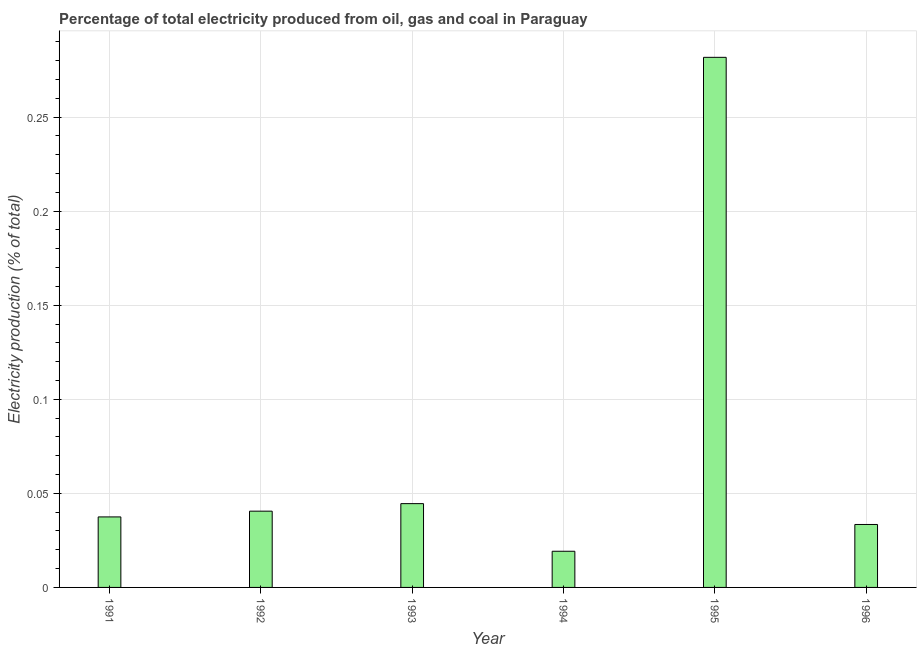Does the graph contain any zero values?
Your answer should be compact. No. What is the title of the graph?
Give a very brief answer. Percentage of total electricity produced from oil, gas and coal in Paraguay. What is the label or title of the Y-axis?
Offer a very short reply. Electricity production (% of total). What is the electricity production in 1993?
Your answer should be very brief. 0.04. Across all years, what is the maximum electricity production?
Provide a succinct answer. 0.28. Across all years, what is the minimum electricity production?
Your answer should be compact. 0.02. In which year was the electricity production minimum?
Offer a terse response. 1994. What is the sum of the electricity production?
Provide a short and direct response. 0.46. What is the difference between the electricity production in 1991 and 1996?
Provide a succinct answer. 0. What is the average electricity production per year?
Make the answer very short. 0.08. What is the median electricity production?
Make the answer very short. 0.04. In how many years, is the electricity production greater than 0.05 %?
Make the answer very short. 1. Do a majority of the years between 1994 and 1996 (inclusive) have electricity production greater than 0.01 %?
Provide a short and direct response. Yes. What is the ratio of the electricity production in 1995 to that in 1996?
Your answer should be compact. 8.42. Is the electricity production in 1992 less than that in 1993?
Ensure brevity in your answer.  Yes. Is the difference between the electricity production in 1995 and 1996 greater than the difference between any two years?
Offer a very short reply. No. What is the difference between the highest and the second highest electricity production?
Provide a short and direct response. 0.24. Is the sum of the electricity production in 1991 and 1994 greater than the maximum electricity production across all years?
Your answer should be very brief. No. What is the difference between the highest and the lowest electricity production?
Your answer should be compact. 0.26. In how many years, is the electricity production greater than the average electricity production taken over all years?
Your answer should be very brief. 1. How many bars are there?
Offer a terse response. 6. Are all the bars in the graph horizontal?
Make the answer very short. No. How many years are there in the graph?
Make the answer very short. 6. Are the values on the major ticks of Y-axis written in scientific E-notation?
Provide a succinct answer. No. What is the Electricity production (% of total) of 1991?
Offer a very short reply. 0.04. What is the Electricity production (% of total) in 1992?
Your response must be concise. 0.04. What is the Electricity production (% of total) of 1993?
Provide a short and direct response. 0.04. What is the Electricity production (% of total) of 1994?
Your answer should be compact. 0.02. What is the Electricity production (% of total) in 1995?
Your response must be concise. 0.28. What is the Electricity production (% of total) in 1996?
Make the answer very short. 0.03. What is the difference between the Electricity production (% of total) in 1991 and 1992?
Offer a terse response. -0. What is the difference between the Electricity production (% of total) in 1991 and 1993?
Provide a succinct answer. -0.01. What is the difference between the Electricity production (% of total) in 1991 and 1994?
Your answer should be compact. 0.02. What is the difference between the Electricity production (% of total) in 1991 and 1995?
Provide a succinct answer. -0.24. What is the difference between the Electricity production (% of total) in 1991 and 1996?
Ensure brevity in your answer.  0. What is the difference between the Electricity production (% of total) in 1992 and 1993?
Offer a very short reply. -0. What is the difference between the Electricity production (% of total) in 1992 and 1994?
Provide a succinct answer. 0.02. What is the difference between the Electricity production (% of total) in 1992 and 1995?
Your response must be concise. -0.24. What is the difference between the Electricity production (% of total) in 1992 and 1996?
Make the answer very short. 0.01. What is the difference between the Electricity production (% of total) in 1993 and 1994?
Offer a terse response. 0.03. What is the difference between the Electricity production (% of total) in 1993 and 1995?
Offer a terse response. -0.24. What is the difference between the Electricity production (% of total) in 1993 and 1996?
Give a very brief answer. 0.01. What is the difference between the Electricity production (% of total) in 1994 and 1995?
Give a very brief answer. -0.26. What is the difference between the Electricity production (% of total) in 1994 and 1996?
Your answer should be compact. -0.01. What is the difference between the Electricity production (% of total) in 1995 and 1996?
Your answer should be very brief. 0.25. What is the ratio of the Electricity production (% of total) in 1991 to that in 1992?
Your answer should be very brief. 0.93. What is the ratio of the Electricity production (% of total) in 1991 to that in 1993?
Your answer should be compact. 0.84. What is the ratio of the Electricity production (% of total) in 1991 to that in 1994?
Offer a very short reply. 1.95. What is the ratio of the Electricity production (% of total) in 1991 to that in 1995?
Your response must be concise. 0.13. What is the ratio of the Electricity production (% of total) in 1991 to that in 1996?
Give a very brief answer. 1.12. What is the ratio of the Electricity production (% of total) in 1992 to that in 1993?
Ensure brevity in your answer.  0.91. What is the ratio of the Electricity production (% of total) in 1992 to that in 1994?
Give a very brief answer. 2.11. What is the ratio of the Electricity production (% of total) in 1992 to that in 1995?
Offer a very short reply. 0.14. What is the ratio of the Electricity production (% of total) in 1992 to that in 1996?
Your answer should be compact. 1.21. What is the ratio of the Electricity production (% of total) in 1993 to that in 1994?
Make the answer very short. 2.32. What is the ratio of the Electricity production (% of total) in 1993 to that in 1995?
Ensure brevity in your answer.  0.16. What is the ratio of the Electricity production (% of total) in 1993 to that in 1996?
Give a very brief answer. 1.33. What is the ratio of the Electricity production (% of total) in 1994 to that in 1995?
Ensure brevity in your answer.  0.07. What is the ratio of the Electricity production (% of total) in 1994 to that in 1996?
Offer a terse response. 0.57. What is the ratio of the Electricity production (% of total) in 1995 to that in 1996?
Your answer should be very brief. 8.42. 